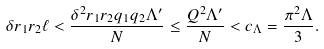<formula> <loc_0><loc_0><loc_500><loc_500>\delta r _ { 1 } r _ { 2 } \ell < \frac { \delta ^ { 2 } r _ { 1 } r _ { 2 } q _ { 1 } q _ { 2 } \Lambda ^ { \prime } } { N } \leq \frac { Q ^ { 2 } \Lambda ^ { \prime } } { N } < c _ { \Lambda } = \frac { \pi ^ { 2 } \Lambda } { 3 } .</formula> 